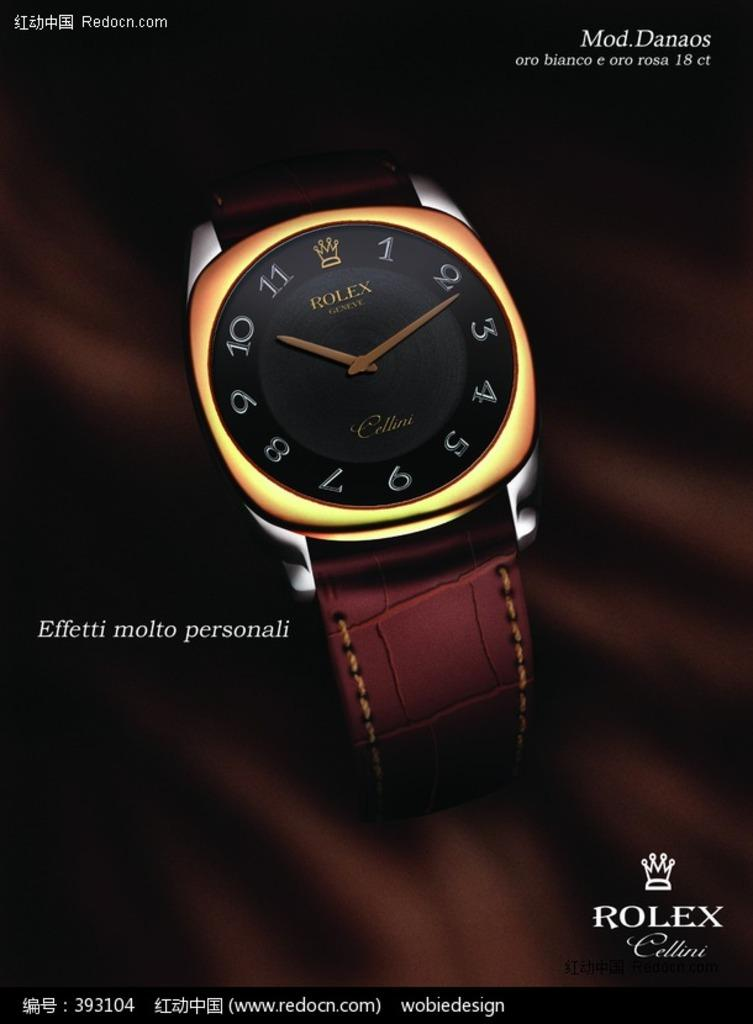Provide a one-sentence caption for the provided image. Rolex watch that is gold and tells the time. 